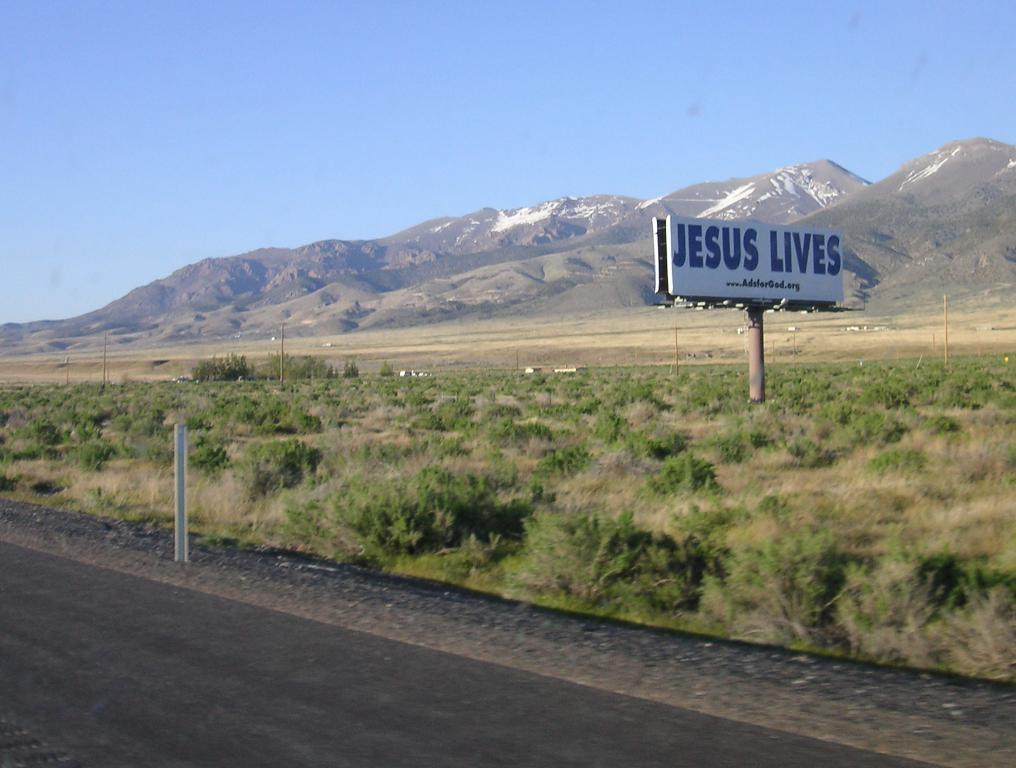Provide a one-sentence caption for the provided image. Jesus Lives banner out in a field by a road way. 